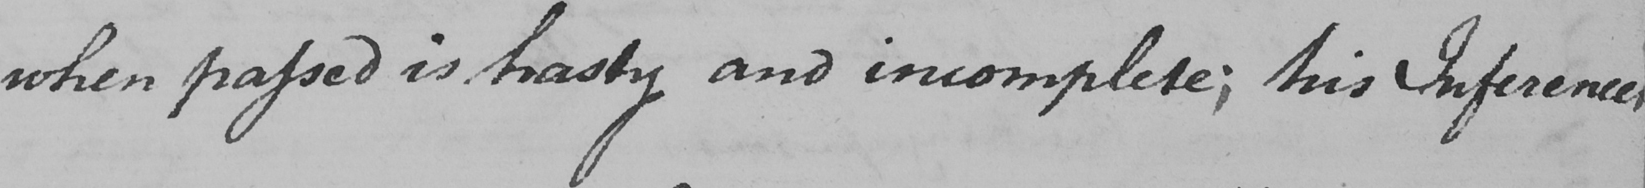Can you tell me what this handwritten text says? when passed is hasty and incomplete ; his Inferences 